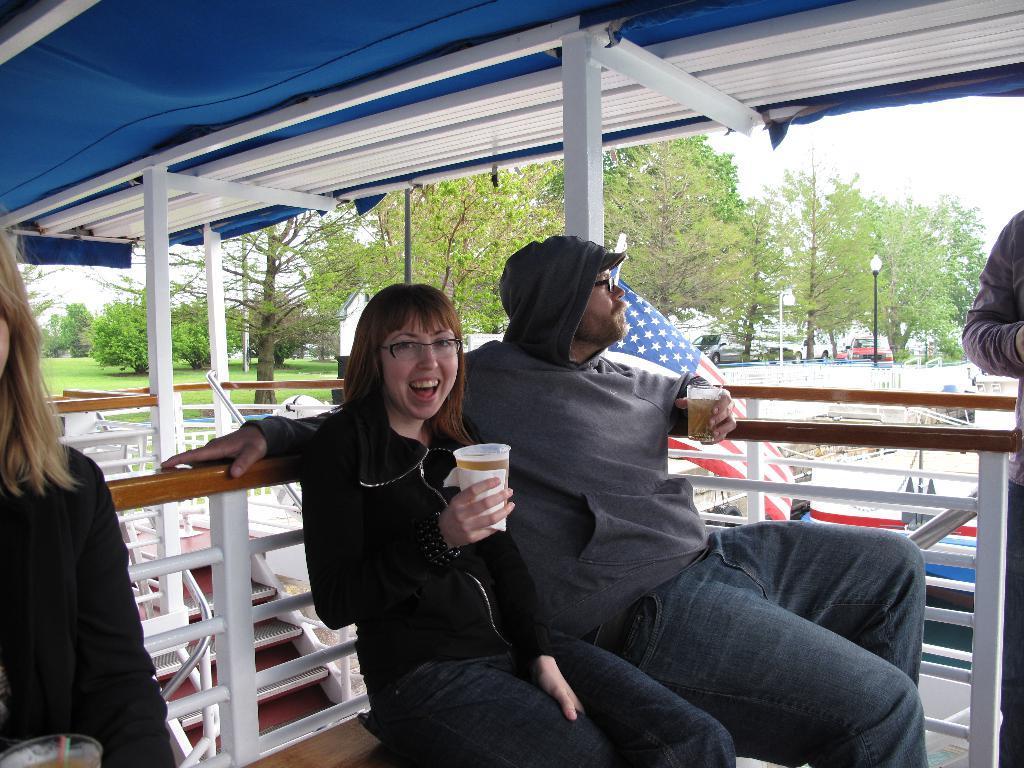Could you give a brief overview of what you see in this image? In this image we can see three persons are sitting on the bench and among them two persons are holding glasses with liquid in it in their hands and on the right side we can see a person is standing and at the bottom corner on the left side we can liquid in a glass. In the background there are trees, poles, objects, vehicles, and sky. 